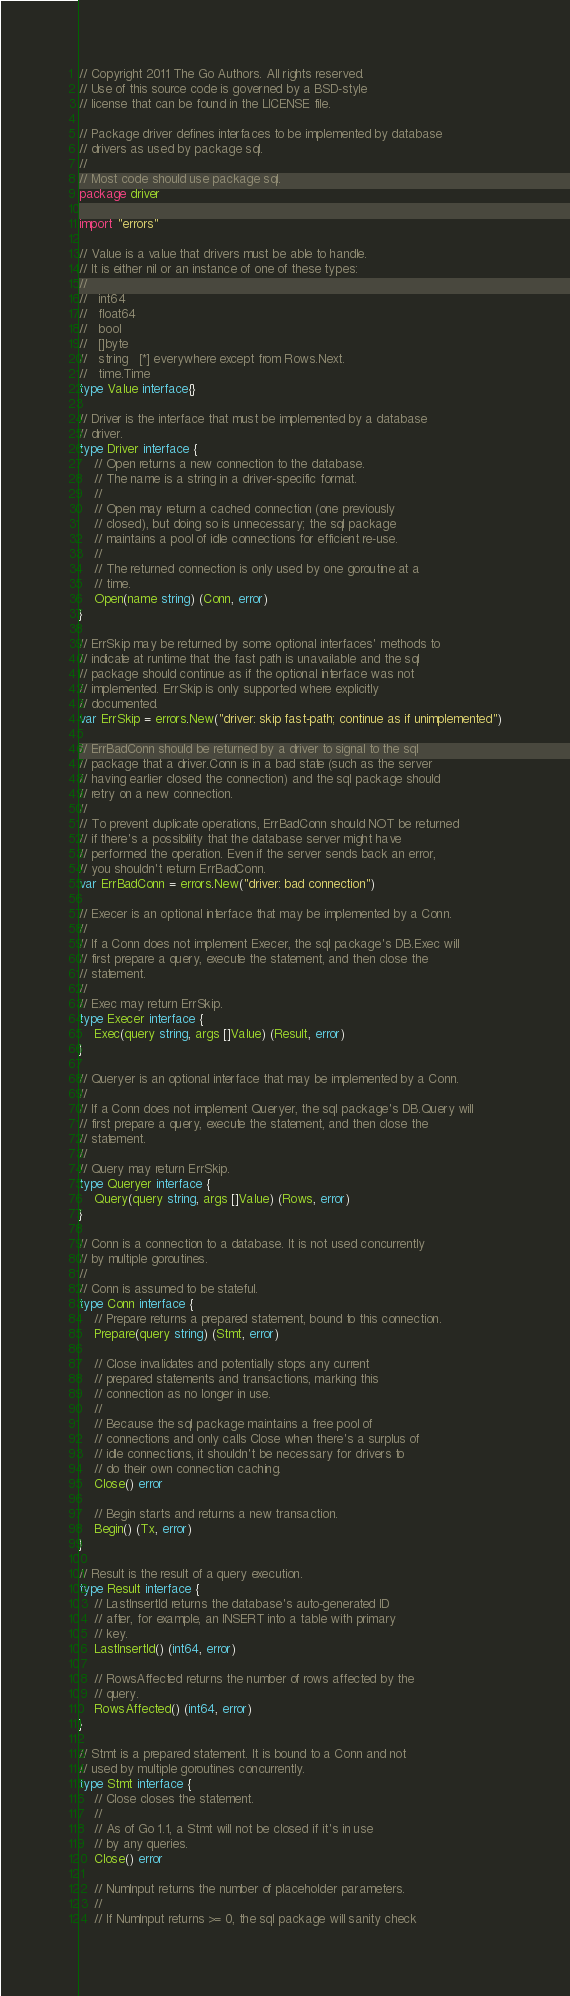<code> <loc_0><loc_0><loc_500><loc_500><_Go_>// Copyright 2011 The Go Authors. All rights reserved.
// Use of this source code is governed by a BSD-style
// license that can be found in the LICENSE file.

// Package driver defines interfaces to be implemented by database
// drivers as used by package sql.
//
// Most code should use package sql.
package driver

import "errors"

// Value is a value that drivers must be able to handle.
// It is either nil or an instance of one of these types:
//
//   int64
//   float64
//   bool
//   []byte
//   string   [*] everywhere except from Rows.Next.
//   time.Time
type Value interface{}

// Driver is the interface that must be implemented by a database
// driver.
type Driver interface {
	// Open returns a new connection to the database.
	// The name is a string in a driver-specific format.
	//
	// Open may return a cached connection (one previously
	// closed), but doing so is unnecessary; the sql package
	// maintains a pool of idle connections for efficient re-use.
	//
	// The returned connection is only used by one goroutine at a
	// time.
	Open(name string) (Conn, error)
}

// ErrSkip may be returned by some optional interfaces' methods to
// indicate at runtime that the fast path is unavailable and the sql
// package should continue as if the optional interface was not
// implemented. ErrSkip is only supported where explicitly
// documented.
var ErrSkip = errors.New("driver: skip fast-path; continue as if unimplemented")

// ErrBadConn should be returned by a driver to signal to the sql
// package that a driver.Conn is in a bad state (such as the server
// having earlier closed the connection) and the sql package should
// retry on a new connection.
//
// To prevent duplicate operations, ErrBadConn should NOT be returned
// if there's a possibility that the database server might have
// performed the operation. Even if the server sends back an error,
// you shouldn't return ErrBadConn.
var ErrBadConn = errors.New("driver: bad connection")

// Execer is an optional interface that may be implemented by a Conn.
//
// If a Conn does not implement Execer, the sql package's DB.Exec will
// first prepare a query, execute the statement, and then close the
// statement.
//
// Exec may return ErrSkip.
type Execer interface {
	Exec(query string, args []Value) (Result, error)
}

// Queryer is an optional interface that may be implemented by a Conn.
//
// If a Conn does not implement Queryer, the sql package's DB.Query will
// first prepare a query, execute the statement, and then close the
// statement.
//
// Query may return ErrSkip.
type Queryer interface {
	Query(query string, args []Value) (Rows, error)
}

// Conn is a connection to a database. It is not used concurrently
// by multiple goroutines.
//
// Conn is assumed to be stateful.
type Conn interface {
	// Prepare returns a prepared statement, bound to this connection.
	Prepare(query string) (Stmt, error)

	// Close invalidates and potentially stops any current
	// prepared statements and transactions, marking this
	// connection as no longer in use.
	//
	// Because the sql package maintains a free pool of
	// connections and only calls Close when there's a surplus of
	// idle connections, it shouldn't be necessary for drivers to
	// do their own connection caching.
	Close() error

	// Begin starts and returns a new transaction.
	Begin() (Tx, error)
}

// Result is the result of a query execution.
type Result interface {
	// LastInsertId returns the database's auto-generated ID
	// after, for example, an INSERT into a table with primary
	// key.
	LastInsertId() (int64, error)

	// RowsAffected returns the number of rows affected by the
	// query.
	RowsAffected() (int64, error)
}

// Stmt is a prepared statement. It is bound to a Conn and not
// used by multiple goroutines concurrently.
type Stmt interface {
	// Close closes the statement.
	//
	// As of Go 1.1, a Stmt will not be closed if it's in use
	// by any queries.
	Close() error

	// NumInput returns the number of placeholder parameters.
	//
	// If NumInput returns >= 0, the sql package will sanity check</code> 